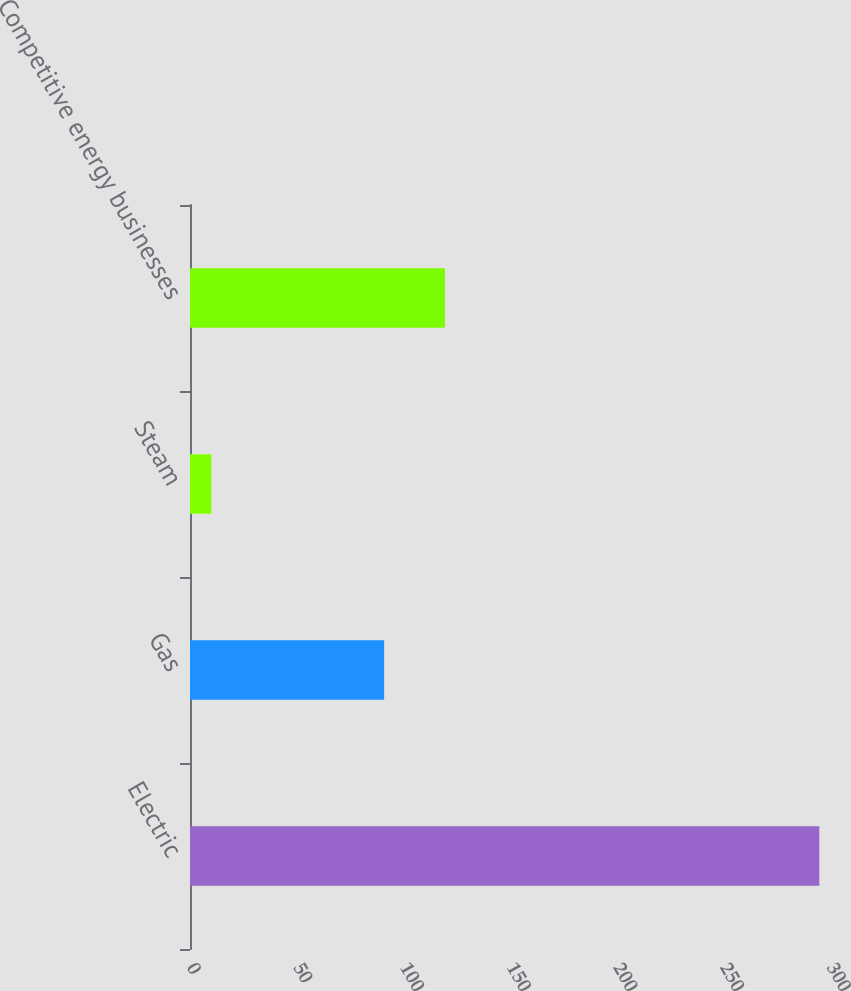Convert chart to OTSL. <chart><loc_0><loc_0><loc_500><loc_500><bar_chart><fcel>Electric<fcel>Gas<fcel>Steam<fcel>Competitive energy businesses<nl><fcel>295<fcel>91<fcel>10<fcel>119.5<nl></chart> 